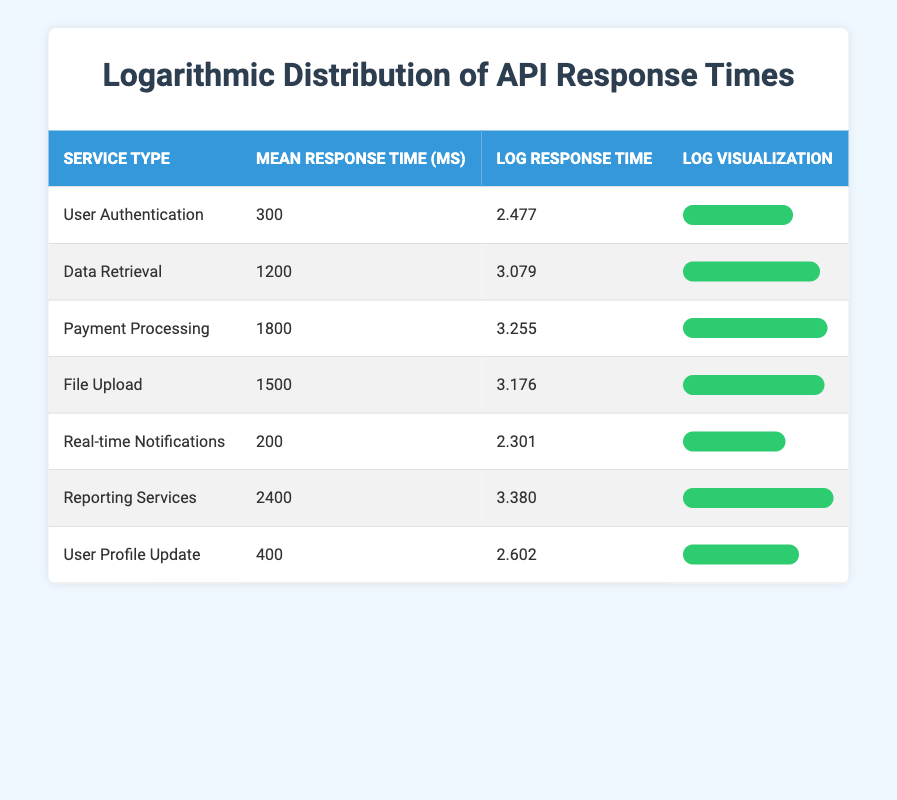What is the mean response time for Payment Processing? Payment Processing has a mean response time listed in the table as 1800 ms.
Answer: 1800 ms Which service type has the highest log response time? By comparing the log response time values, Reporting Services has the highest value at 3.380.
Answer: Reporting Services What is the difference in mean response time between Data Retrieval and Real-time Notifications? The mean response time for Data Retrieval is 1200 ms and for Real-time Notifications, it is 200 ms. The difference is 1200 - 200 = 1000 ms.
Answer: 1000 ms Is the mean response time for User Authentication greater than 250 ms? The mean response time for User Authentication is 300 ms, which is greater than 250 ms.
Answer: Yes What is the average mean response time for all listed service types? To find the average, sum the mean response times: (300 + 1200 + 1800 + 1500 + 200 + 2400 + 400) = 5800 ms. There are 7 services, so the average is 5800 / 7 ≈ 828.57 ms.
Answer: Approximately 828.57 ms Which service type has a log response time less than 3? Comparing the log response times, Real-time Notifications (2.301) and User Authentication (2.477) both have values less than 3.
Answer: Real-time Notifications and User Authentication What is the total mean response time for Payment Processing and File Upload combined? The mean response time for Payment Processing is 1800 ms and for File Upload, it is 1500 ms. Their total is 1800 + 1500 = 3300 ms.
Answer: 3300 ms Are there more service types with a mean response time above 1000 ms or below? There are 4 service types with a mean response time above 1000 ms (Data Retrieval, Payment Processing, File Upload, Reporting Services) and 3 below (User Authentication, Real-time Notifications, User Profile Update). Thus, there are more above 1000 ms.
Answer: Above 1000 ms What percentage of the mean response time for Reporting Services (2400 ms) does the mean response time for User Profile Update (400 ms) represent? To find the percentage, use the formula: (400 / 2400) * 100 = 16.67%.
Answer: 16.67% 